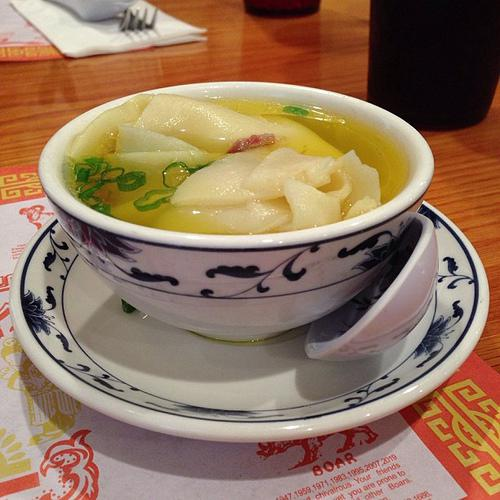Question: how many cups can be seen?
Choices:
A. Three.
B. Four.
C. None.
D. Two.
Answer with the letter. Answer: D Question: where was this photo taken?
Choices:
A. In the city.
B. At a Chinese restaurant.
C. At a fair.
D. At the beach.
Answer with the letter. Answer: B Question: when was this photo taken?
Choices:
A. Meal time.
B. In the evening.
C. In the winter.
D. In the morning.
Answer with the letter. Answer: A 